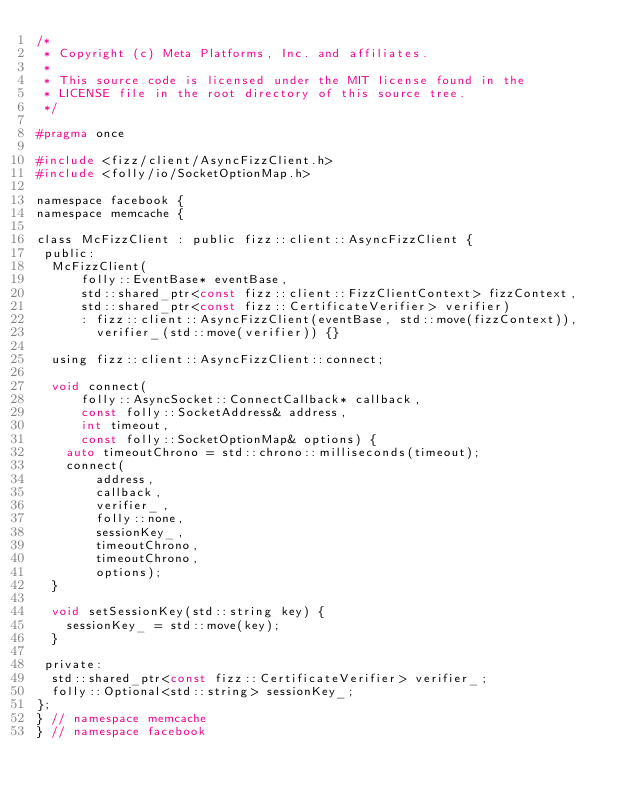<code> <loc_0><loc_0><loc_500><loc_500><_C_>/*
 * Copyright (c) Meta Platforms, Inc. and affiliates.
 *
 * This source code is licensed under the MIT license found in the
 * LICENSE file in the root directory of this source tree.
 */

#pragma once

#include <fizz/client/AsyncFizzClient.h>
#include <folly/io/SocketOptionMap.h>

namespace facebook {
namespace memcache {

class McFizzClient : public fizz::client::AsyncFizzClient {
 public:
  McFizzClient(
      folly::EventBase* eventBase,
      std::shared_ptr<const fizz::client::FizzClientContext> fizzContext,
      std::shared_ptr<const fizz::CertificateVerifier> verifier)
      : fizz::client::AsyncFizzClient(eventBase, std::move(fizzContext)),
        verifier_(std::move(verifier)) {}

  using fizz::client::AsyncFizzClient::connect;

  void connect(
      folly::AsyncSocket::ConnectCallback* callback,
      const folly::SocketAddress& address,
      int timeout,
      const folly::SocketOptionMap& options) {
    auto timeoutChrono = std::chrono::milliseconds(timeout);
    connect(
        address,
        callback,
        verifier_,
        folly::none,
        sessionKey_,
        timeoutChrono,
        timeoutChrono,
        options);
  }

  void setSessionKey(std::string key) {
    sessionKey_ = std::move(key);
  }

 private:
  std::shared_ptr<const fizz::CertificateVerifier> verifier_;
  folly::Optional<std::string> sessionKey_;
};
} // namespace memcache
} // namespace facebook
</code> 